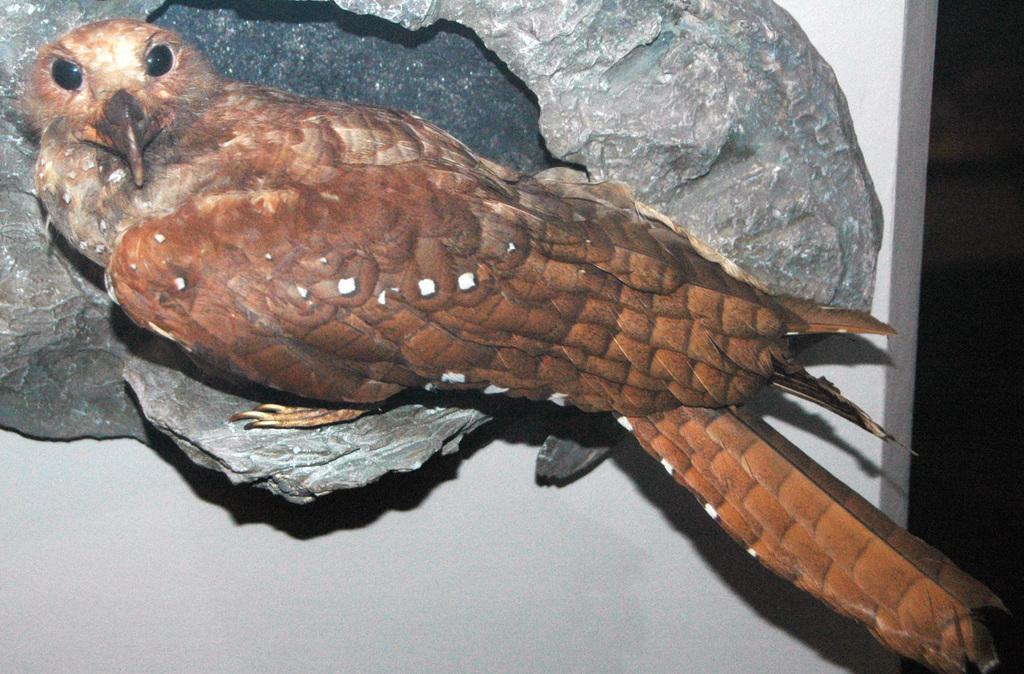What type of animal is on the surface in the image? There is a bird on the surface in the image. What color is the background of the image? The background of the image is white. What type of pot is being used in the battle depicted in the image? There is no battle or pot present in the image; it features a bird on a surface with a white background. 